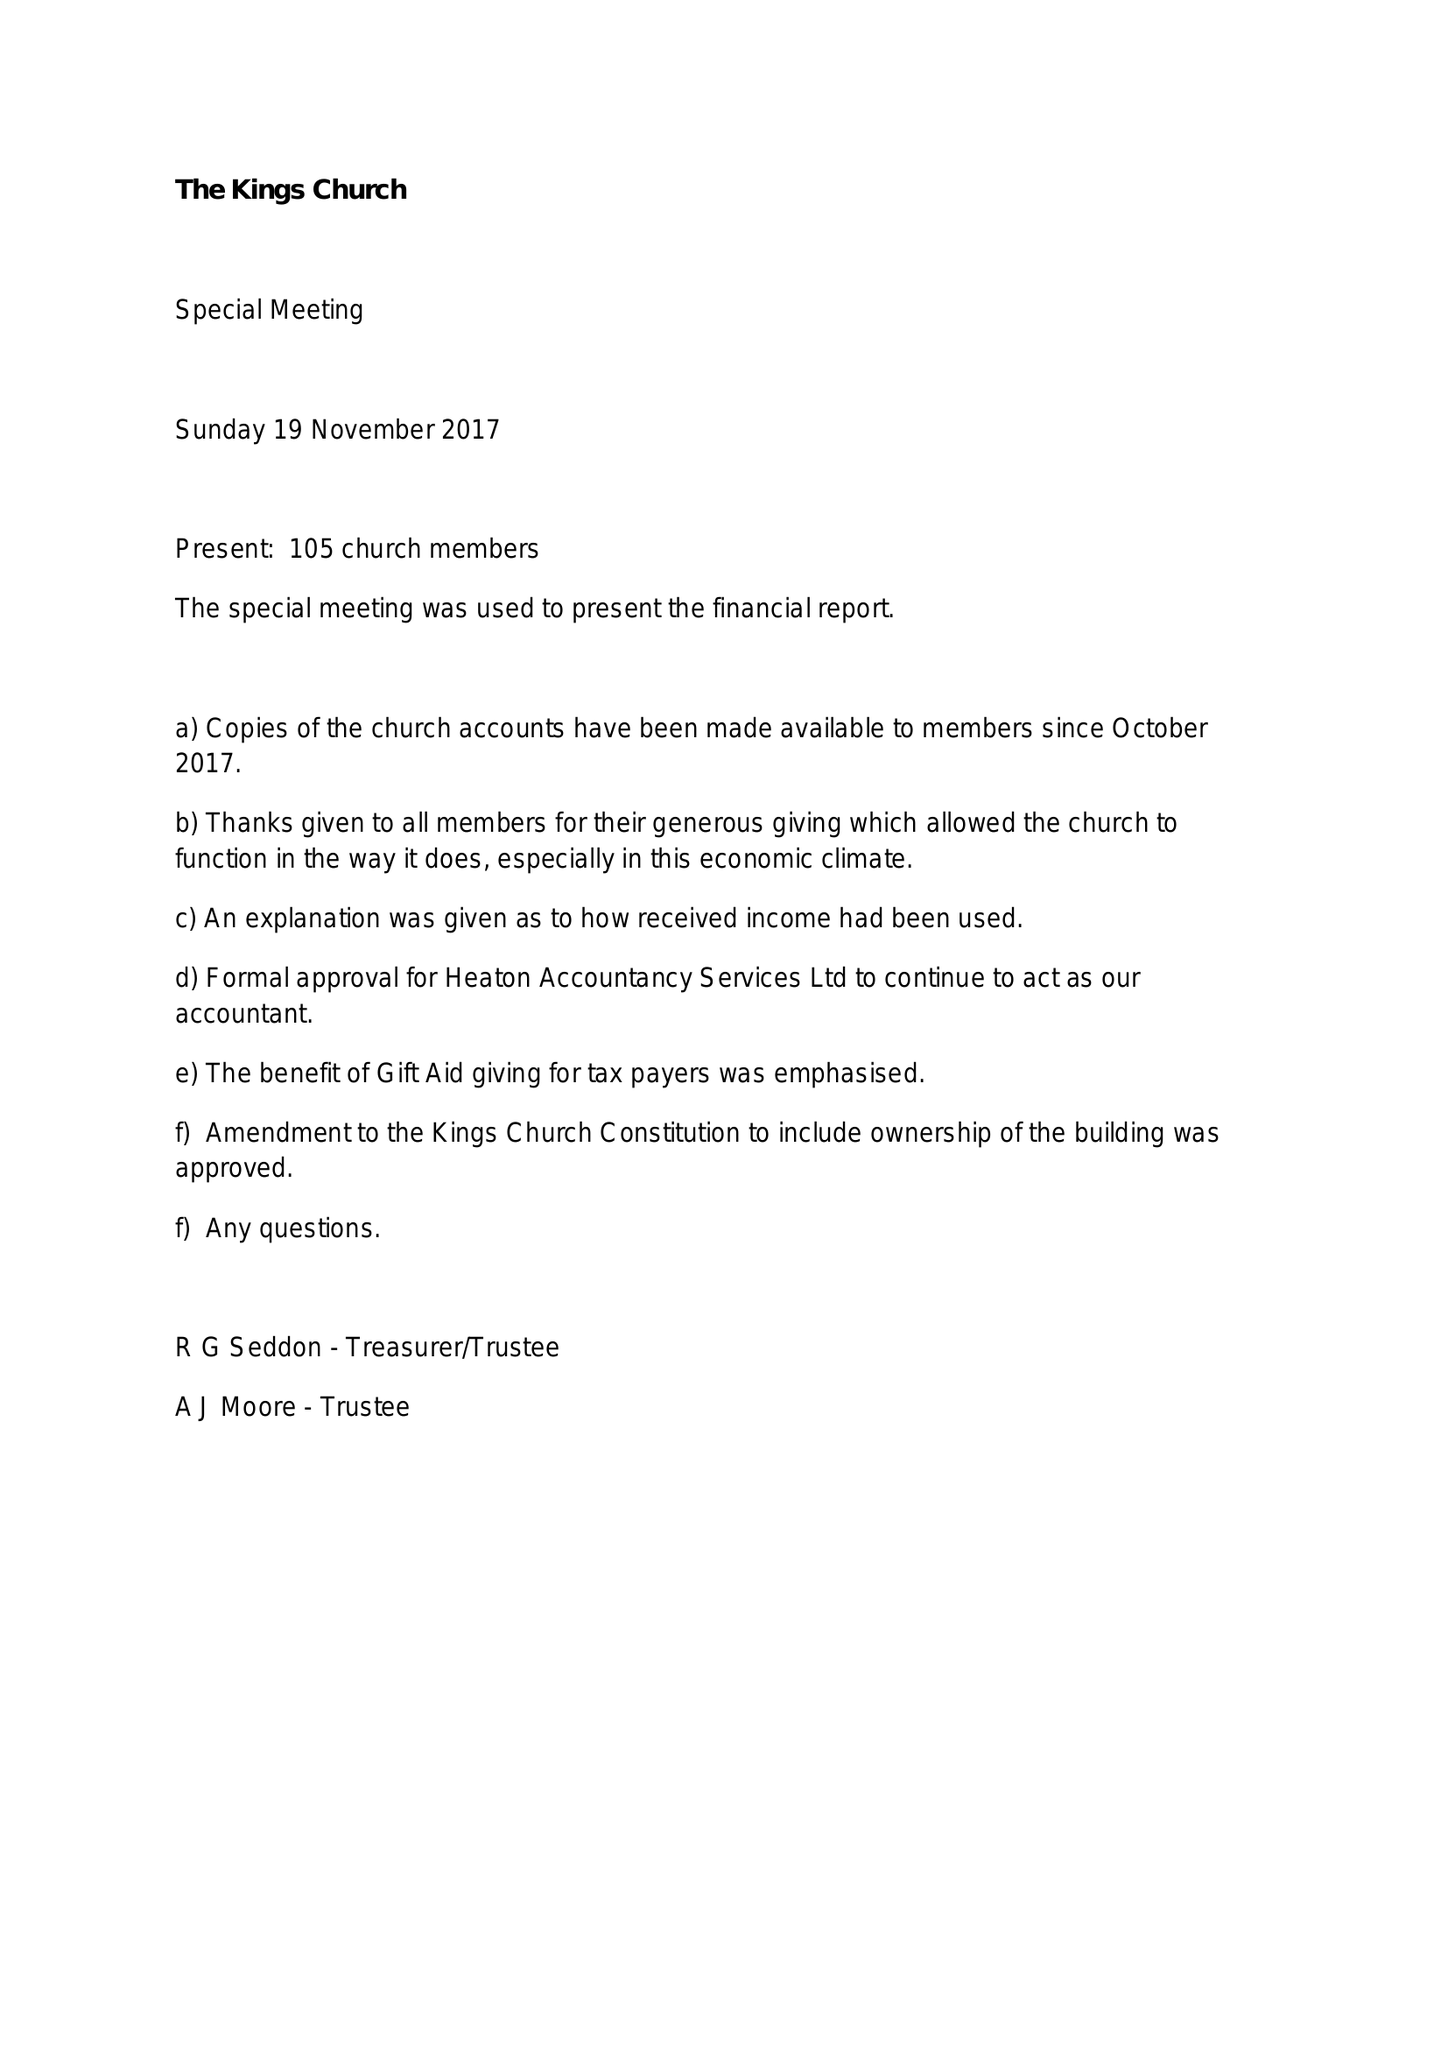What is the value for the address__post_town?
Answer the question using a single word or phrase. BOLTON 